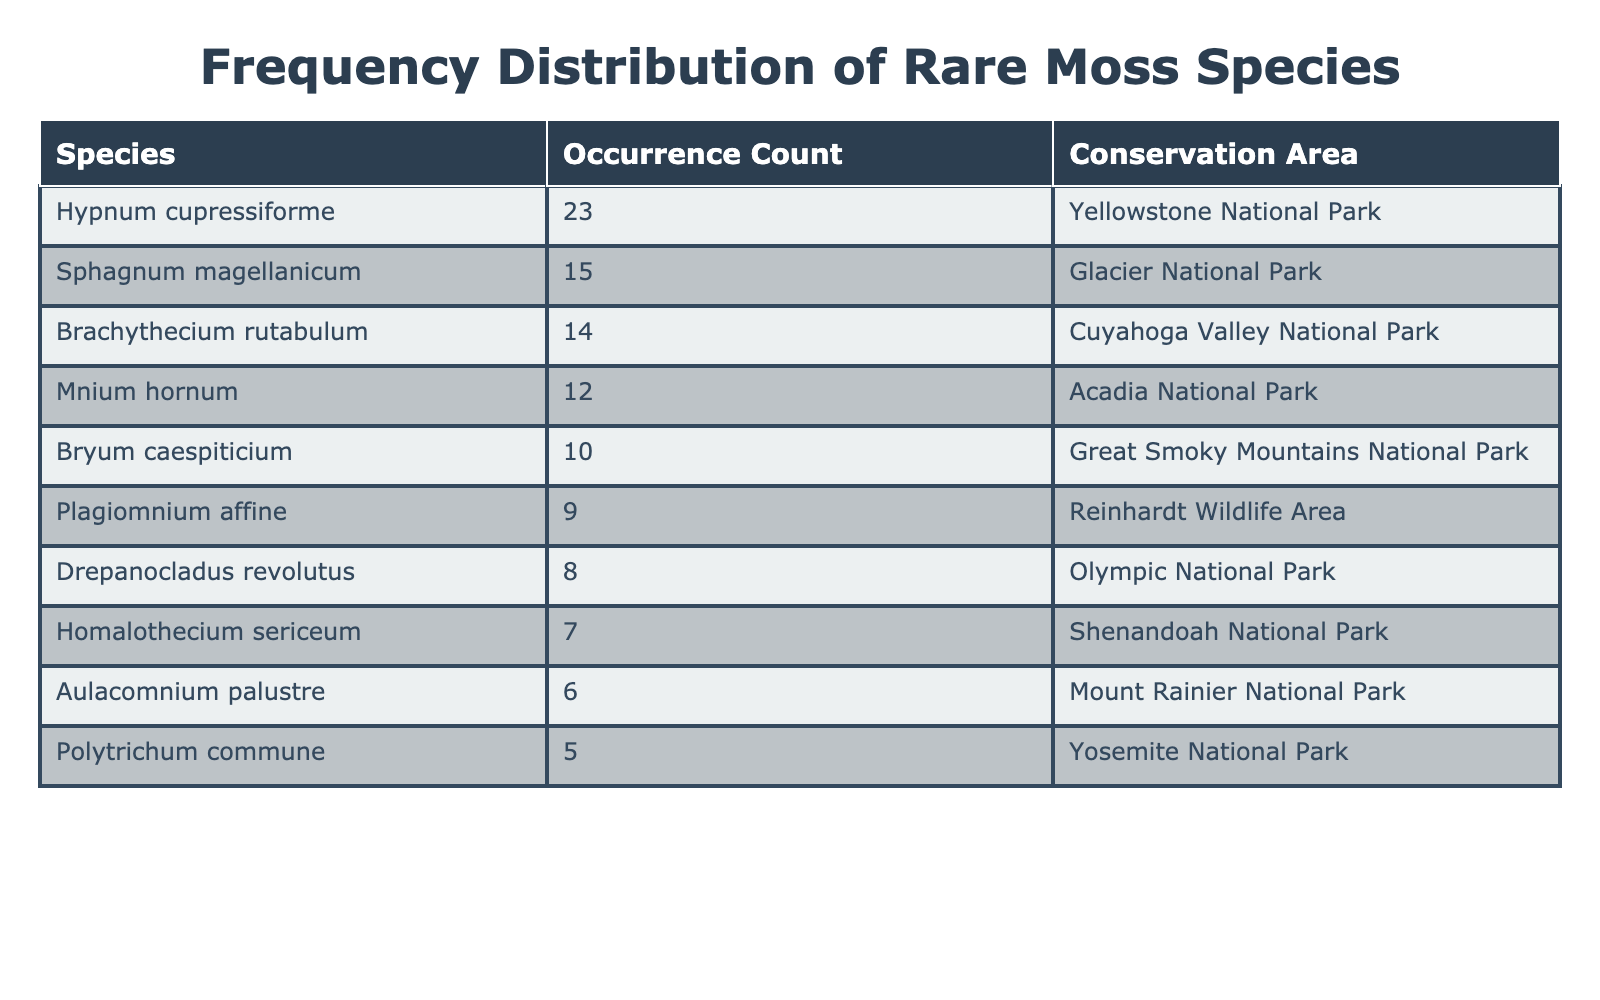What is the occurrence count of Sphagnum magellanicum? The table lists Sphagnum magellanicum in the first row, and the corresponding occurrence count is 15.
Answer: 15 Which conservation area has the highest occurrence of moss species? By observing the Occurrence_Count column, Hypnum cupressiforme has the highest occurrence count of 23, thus it is associated with Yellowstone National Park, making it the area with the highest occurrence.
Answer: Yellowstone National Park What is the total occurrence count of moss species in the Great Smoky Mountains National Park and Yosemite National Park? The occurrence count in Great Smoky Mountains National Park is 10 (Bryum caespiticium) and in Yosemite National Park it is 5 (Polytrichum commune). Adding them together, 10 + 5 equals 15.
Answer: 15 Is there a moss species found in more than one conservation area? Based on the table, each moss species is uniquely associated with a single conservation area, as there are no repeated entries for species across different areas. Thus, the answer is no.
Answer: No What is the average occurrence count of all the moss species listed in the table? First, add all the occurrence counts: 15 + 23 + 10 + 5 + 8 + 12 + 7 + 6 + 14 + 9 = 109. Since there are 10 species, the average occurrence count is 109 divided by 10, which equals 10.9.
Answer: 10.9 Which species has the least occurrence count among those listed? The species with the least occurrence count in the table is Polytrichum commune, which has an occurrence count of 5, making it the lowest in that regard.
Answer: Polytrichum commune How many species have an occurrence count less than 10? Looking through the Occurrence_Count column, the species with less than 10 occurrences are Polytrichum commune (5), Drepanocladus revolutus (8), Homalothecium sericeum (7), and Aulacomnium palustre (6), totaling four species.
Answer: 4 Are there more than three species listed from conservation areas in the western United States? By examining the conservation areas, we see that Glacier National Park, Yellowstone National Park, and Olympic National Park are in the western United States, but only Olympic National Park has a moss species listed, so the answer is no.
Answer: No 